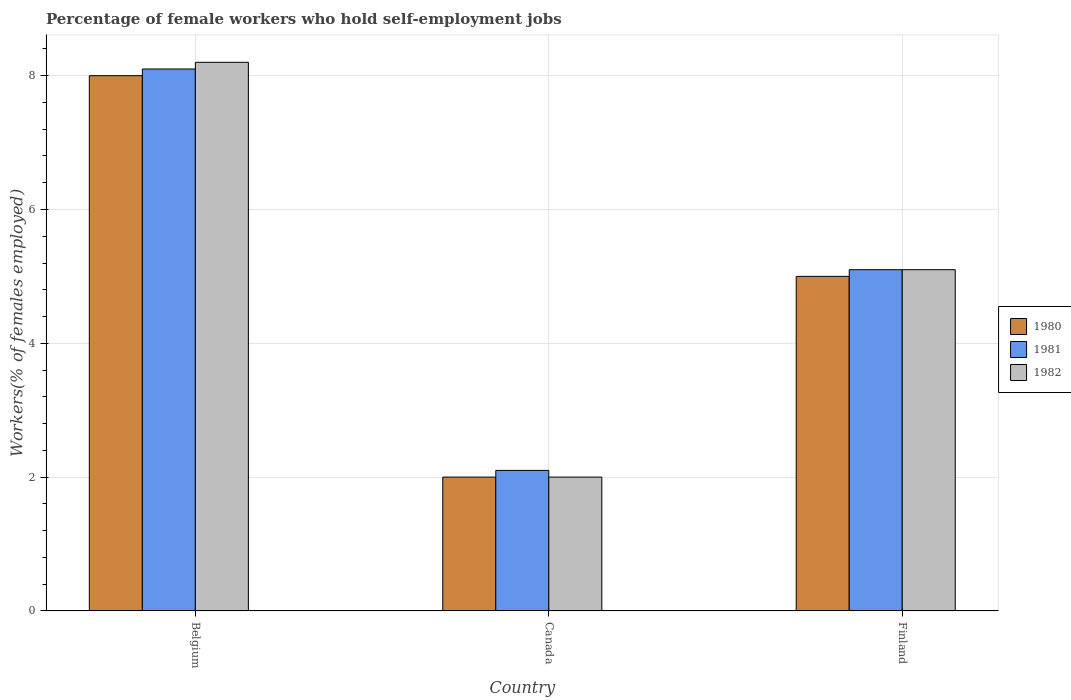How many groups of bars are there?
Offer a terse response. 3. Are the number of bars on each tick of the X-axis equal?
Give a very brief answer. Yes. How many bars are there on the 1st tick from the left?
Your response must be concise. 3. In how many cases, is the number of bars for a given country not equal to the number of legend labels?
Give a very brief answer. 0. What is the percentage of self-employed female workers in 1980 in Belgium?
Your response must be concise. 8. Across all countries, what is the minimum percentage of self-employed female workers in 1981?
Offer a very short reply. 2.1. In which country was the percentage of self-employed female workers in 1980 maximum?
Provide a short and direct response. Belgium. What is the total percentage of self-employed female workers in 1982 in the graph?
Your response must be concise. 15.3. What is the difference between the percentage of self-employed female workers in 1980 in Belgium and that in Canada?
Keep it short and to the point. 6. What is the difference between the percentage of self-employed female workers in 1980 in Belgium and the percentage of self-employed female workers in 1981 in Canada?
Ensure brevity in your answer.  5.9. What is the average percentage of self-employed female workers in 1981 per country?
Ensure brevity in your answer.  5.1. What is the difference between the percentage of self-employed female workers of/in 1982 and percentage of self-employed female workers of/in 1980 in Finland?
Ensure brevity in your answer.  0.1. What is the ratio of the percentage of self-employed female workers in 1982 in Belgium to that in Canada?
Provide a succinct answer. 4.1. What is the difference between the highest and the lowest percentage of self-employed female workers in 1982?
Give a very brief answer. 6.2. In how many countries, is the percentage of self-employed female workers in 1980 greater than the average percentage of self-employed female workers in 1980 taken over all countries?
Your answer should be compact. 1. What does the 3rd bar from the left in Canada represents?
Your response must be concise. 1982. What does the 1st bar from the right in Canada represents?
Your response must be concise. 1982. Is it the case that in every country, the sum of the percentage of self-employed female workers in 1980 and percentage of self-employed female workers in 1981 is greater than the percentage of self-employed female workers in 1982?
Ensure brevity in your answer.  Yes. What is the difference between two consecutive major ticks on the Y-axis?
Ensure brevity in your answer.  2. Are the values on the major ticks of Y-axis written in scientific E-notation?
Your answer should be compact. No. Does the graph contain grids?
Your answer should be compact. Yes. Where does the legend appear in the graph?
Your response must be concise. Center right. How many legend labels are there?
Your answer should be compact. 3. What is the title of the graph?
Give a very brief answer. Percentage of female workers who hold self-employment jobs. Does "1969" appear as one of the legend labels in the graph?
Your response must be concise. No. What is the label or title of the Y-axis?
Keep it short and to the point. Workers(% of females employed). What is the Workers(% of females employed) of 1980 in Belgium?
Ensure brevity in your answer.  8. What is the Workers(% of females employed) in 1981 in Belgium?
Make the answer very short. 8.1. What is the Workers(% of females employed) of 1982 in Belgium?
Your response must be concise. 8.2. What is the Workers(% of females employed) in 1981 in Canada?
Your response must be concise. 2.1. What is the Workers(% of females employed) in 1982 in Canada?
Your answer should be very brief. 2. What is the Workers(% of females employed) in 1980 in Finland?
Offer a very short reply. 5. What is the Workers(% of females employed) in 1981 in Finland?
Give a very brief answer. 5.1. What is the Workers(% of females employed) in 1982 in Finland?
Your answer should be compact. 5.1. Across all countries, what is the maximum Workers(% of females employed) in 1981?
Make the answer very short. 8.1. Across all countries, what is the maximum Workers(% of females employed) in 1982?
Give a very brief answer. 8.2. Across all countries, what is the minimum Workers(% of females employed) of 1981?
Your response must be concise. 2.1. What is the total Workers(% of females employed) of 1980 in the graph?
Offer a terse response. 15. What is the difference between the Workers(% of females employed) of 1980 in Belgium and that in Canada?
Provide a short and direct response. 6. What is the difference between the Workers(% of females employed) of 1980 in Belgium and that in Finland?
Provide a succinct answer. 3. What is the difference between the Workers(% of females employed) of 1981 in Belgium and that in Finland?
Make the answer very short. 3. What is the difference between the Workers(% of females employed) in 1982 in Belgium and that in Finland?
Your answer should be compact. 3.1. What is the difference between the Workers(% of females employed) of 1980 in Belgium and the Workers(% of females employed) of 1981 in Canada?
Provide a succinct answer. 5.9. What is the difference between the Workers(% of females employed) of 1981 in Belgium and the Workers(% of females employed) of 1982 in Canada?
Offer a very short reply. 6.1. What is the difference between the Workers(% of females employed) in 1980 in Belgium and the Workers(% of females employed) in 1981 in Finland?
Your answer should be compact. 2.9. What is the difference between the Workers(% of females employed) of 1980 in Belgium and the Workers(% of females employed) of 1982 in Finland?
Your answer should be compact. 2.9. What is the difference between the Workers(% of females employed) of 1981 in Belgium and the Workers(% of females employed) of 1982 in Finland?
Offer a terse response. 3. What is the difference between the Workers(% of females employed) in 1980 in Canada and the Workers(% of females employed) in 1981 in Finland?
Provide a short and direct response. -3.1. What is the difference between the Workers(% of females employed) of 1981 in Canada and the Workers(% of females employed) of 1982 in Finland?
Your answer should be very brief. -3. What is the average Workers(% of females employed) in 1980 per country?
Your answer should be very brief. 5. What is the average Workers(% of females employed) of 1981 per country?
Your answer should be very brief. 5.1. What is the difference between the Workers(% of females employed) of 1980 and Workers(% of females employed) of 1981 in Belgium?
Offer a terse response. -0.1. What is the difference between the Workers(% of females employed) in 1980 and Workers(% of females employed) in 1982 in Belgium?
Your answer should be compact. -0.2. What is the difference between the Workers(% of females employed) in 1980 and Workers(% of females employed) in 1982 in Canada?
Give a very brief answer. 0. What is the difference between the Workers(% of females employed) in 1981 and Workers(% of females employed) in 1982 in Canada?
Offer a very short reply. 0.1. What is the difference between the Workers(% of females employed) of 1980 and Workers(% of females employed) of 1981 in Finland?
Provide a short and direct response. -0.1. What is the ratio of the Workers(% of females employed) in 1980 in Belgium to that in Canada?
Your response must be concise. 4. What is the ratio of the Workers(% of females employed) in 1981 in Belgium to that in Canada?
Provide a short and direct response. 3.86. What is the ratio of the Workers(% of females employed) of 1982 in Belgium to that in Canada?
Your response must be concise. 4.1. What is the ratio of the Workers(% of females employed) of 1980 in Belgium to that in Finland?
Make the answer very short. 1.6. What is the ratio of the Workers(% of females employed) of 1981 in Belgium to that in Finland?
Provide a short and direct response. 1.59. What is the ratio of the Workers(% of females employed) of 1982 in Belgium to that in Finland?
Give a very brief answer. 1.61. What is the ratio of the Workers(% of females employed) of 1981 in Canada to that in Finland?
Provide a succinct answer. 0.41. What is the ratio of the Workers(% of females employed) in 1982 in Canada to that in Finland?
Your answer should be compact. 0.39. What is the difference between the highest and the second highest Workers(% of females employed) in 1980?
Offer a very short reply. 3. What is the difference between the highest and the lowest Workers(% of females employed) in 1980?
Offer a very short reply. 6. What is the difference between the highest and the lowest Workers(% of females employed) of 1981?
Provide a short and direct response. 6. What is the difference between the highest and the lowest Workers(% of females employed) in 1982?
Your answer should be compact. 6.2. 